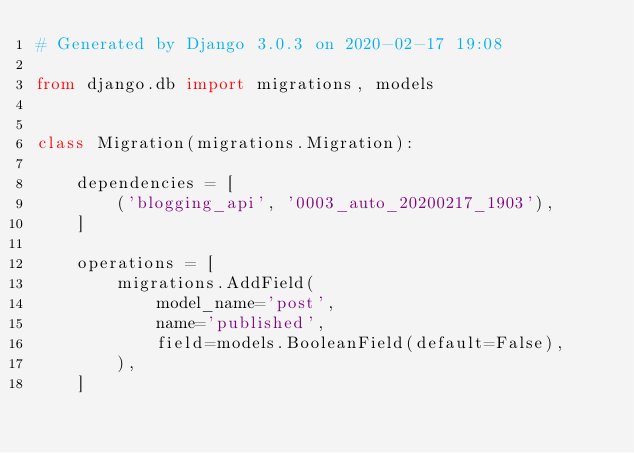Convert code to text. <code><loc_0><loc_0><loc_500><loc_500><_Python_># Generated by Django 3.0.3 on 2020-02-17 19:08

from django.db import migrations, models


class Migration(migrations.Migration):

    dependencies = [
        ('blogging_api', '0003_auto_20200217_1903'),
    ]

    operations = [
        migrations.AddField(
            model_name='post',
            name='published',
            field=models.BooleanField(default=False),
        ),
    ]
</code> 